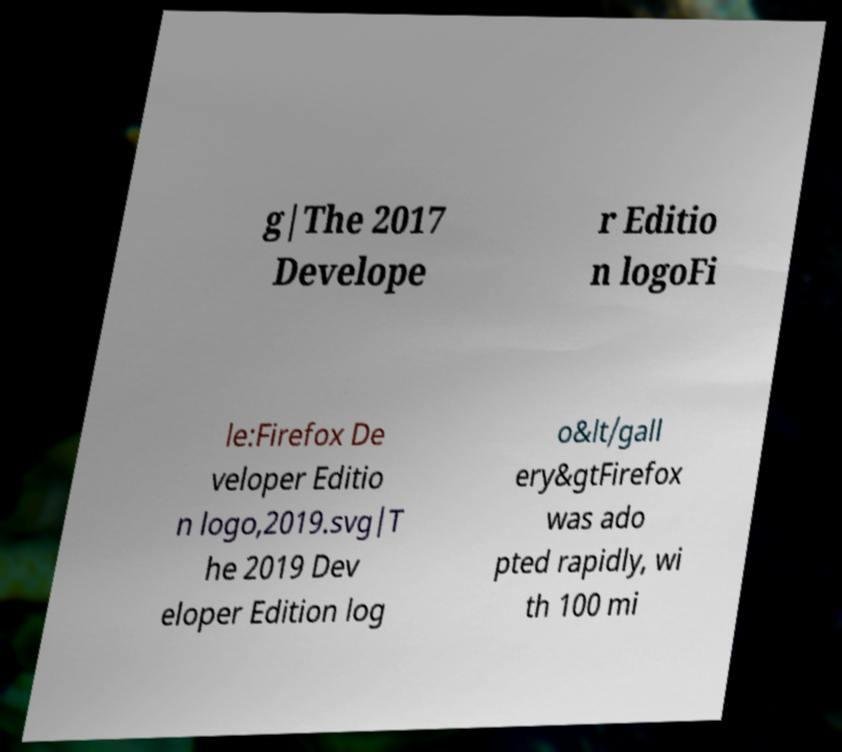Can you read and provide the text displayed in the image?This photo seems to have some interesting text. Can you extract and type it out for me? g|The 2017 Develope r Editio n logoFi le:Firefox De veloper Editio n logo,2019.svg|T he 2019 Dev eloper Edition log o&lt/gall ery&gtFirefox was ado pted rapidly, wi th 100 mi 